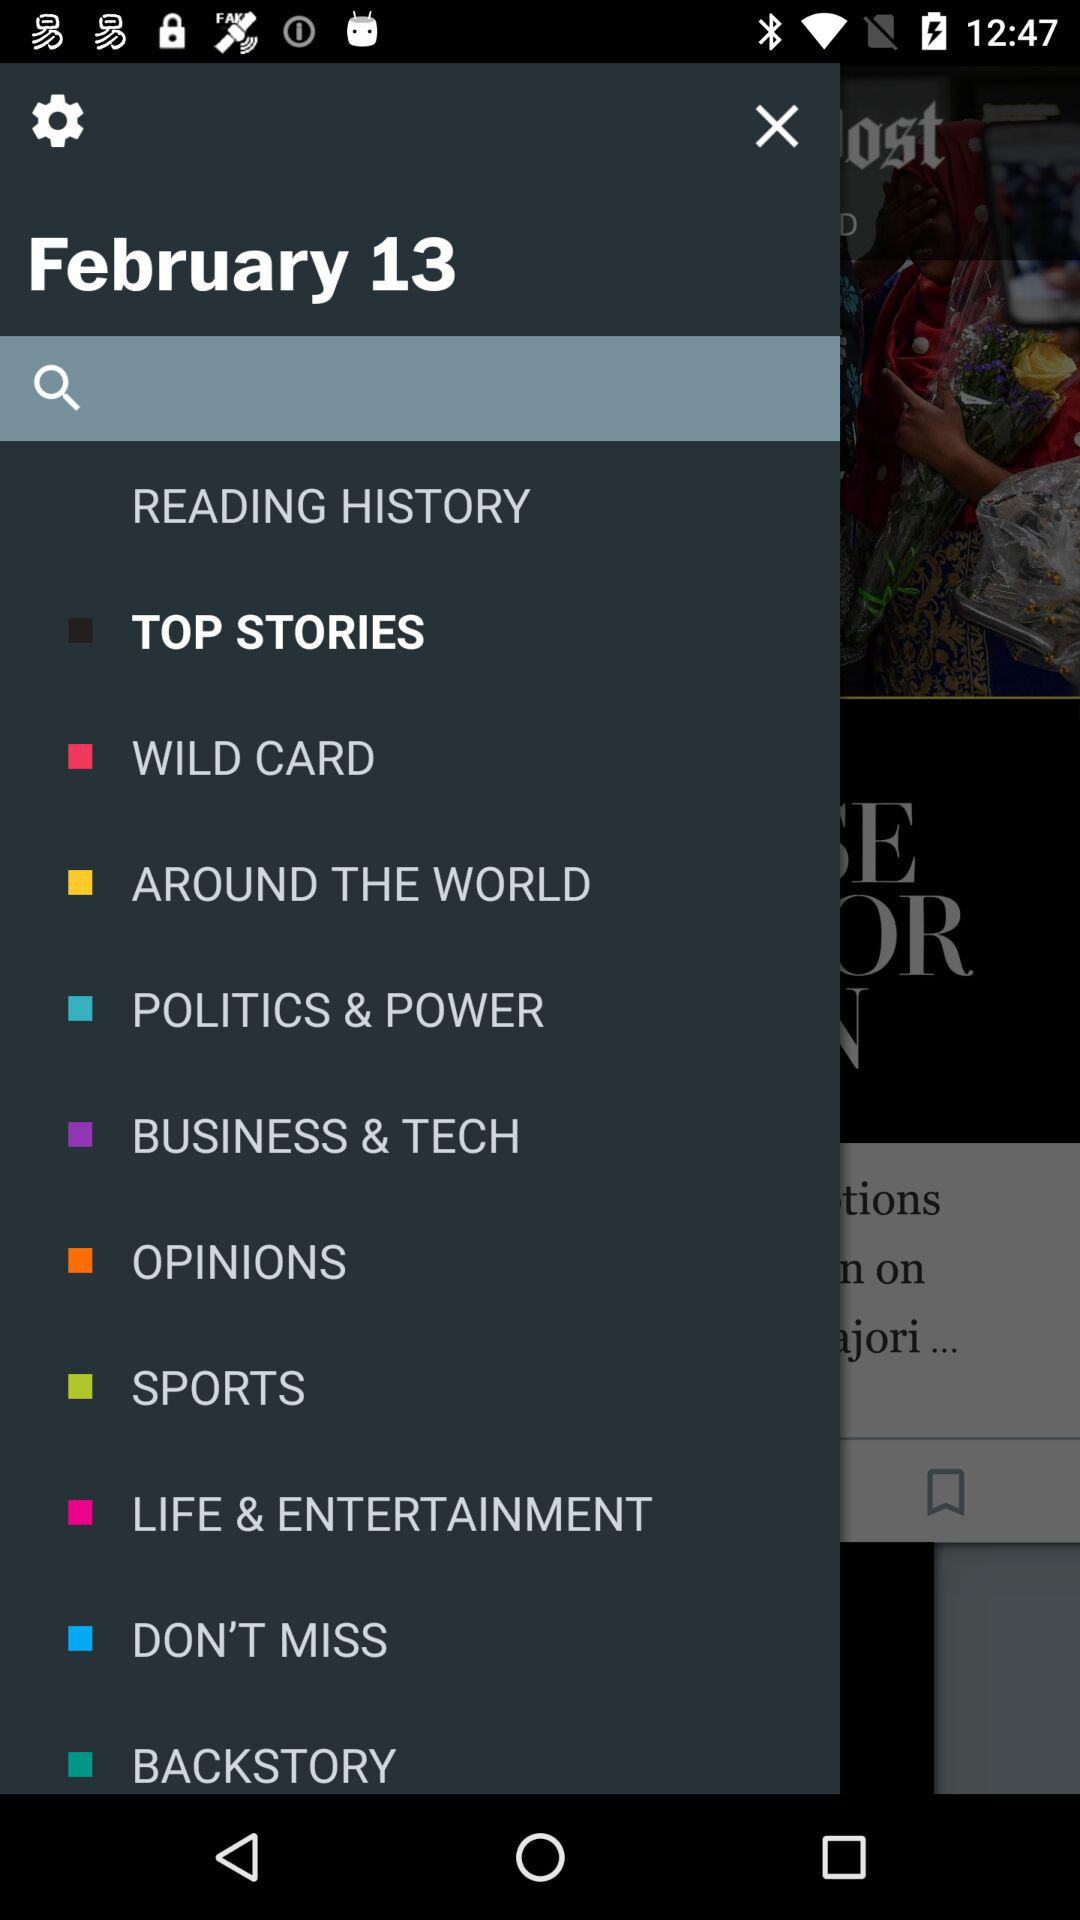What date is shown here? The date is February 13. 